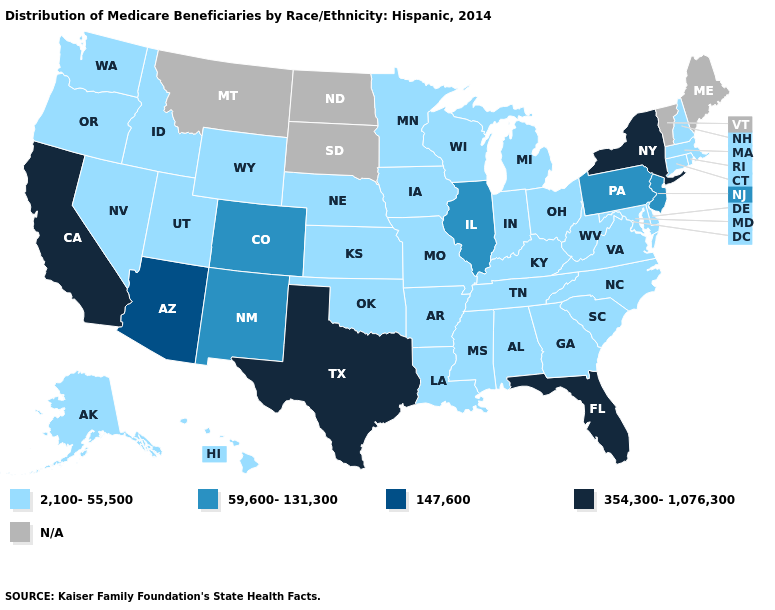Does the first symbol in the legend represent the smallest category?
Short answer required. Yes. What is the value of Arizona?
Be succinct. 147,600. Name the states that have a value in the range N/A?
Keep it brief. Maine, Montana, North Dakota, South Dakota, Vermont. Among the states that border Missouri , does Kansas have the lowest value?
Keep it brief. Yes. Name the states that have a value in the range 354,300-1,076,300?
Write a very short answer. California, Florida, New York, Texas. Does Florida have the lowest value in the USA?
Quick response, please. No. Does Idaho have the lowest value in the USA?
Short answer required. Yes. Is the legend a continuous bar?
Concise answer only. No. Does Illinois have the highest value in the MidWest?
Keep it brief. Yes. Name the states that have a value in the range 354,300-1,076,300?
Be succinct. California, Florida, New York, Texas. Does Michigan have the lowest value in the MidWest?
Give a very brief answer. Yes. What is the value of Oregon?
Give a very brief answer. 2,100-55,500. Name the states that have a value in the range 147,600?
Write a very short answer. Arizona. Among the states that border Wisconsin , does Michigan have the highest value?
Short answer required. No. 